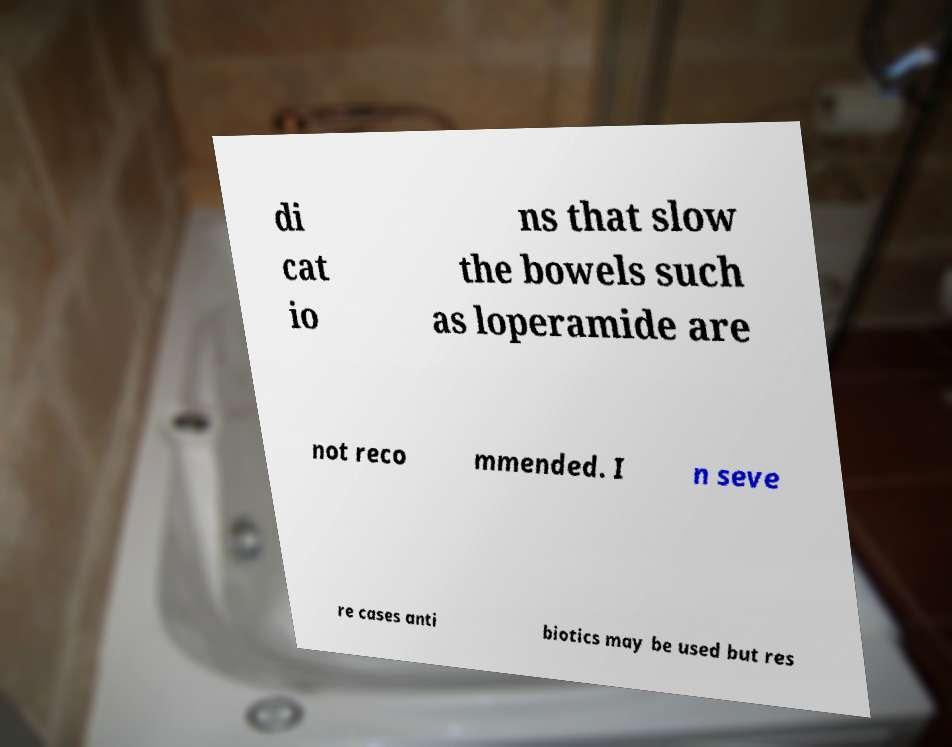Could you assist in decoding the text presented in this image and type it out clearly? di cat io ns that slow the bowels such as loperamide are not reco mmended. I n seve re cases anti biotics may be used but res 